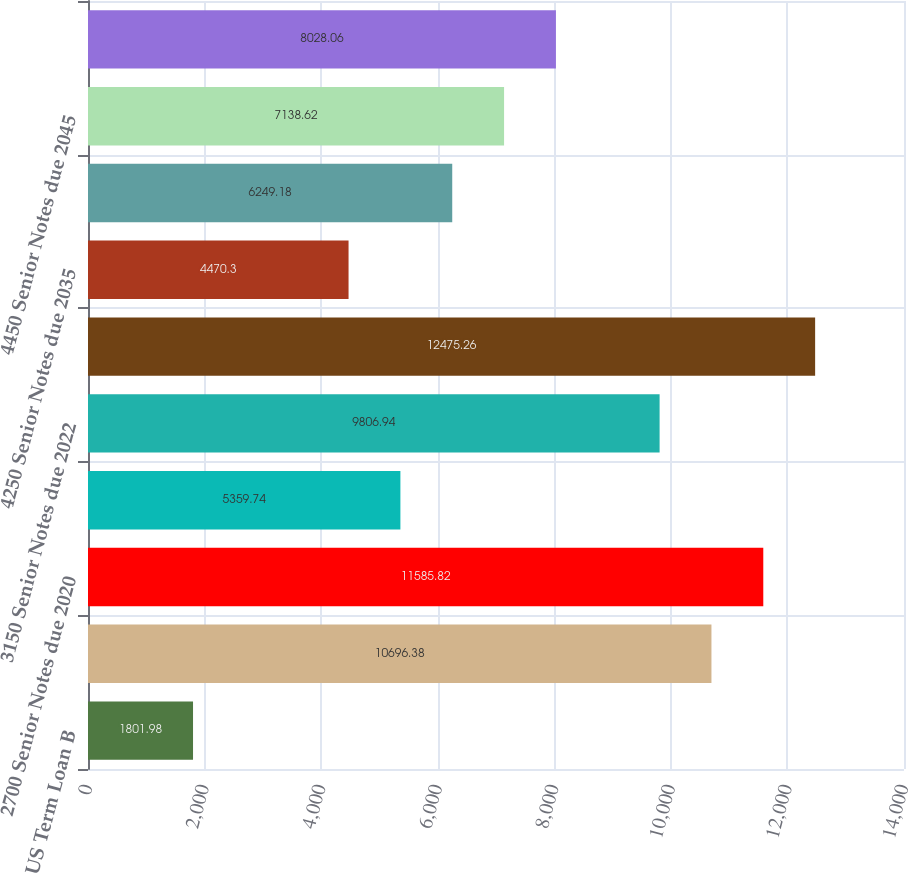<chart> <loc_0><loc_0><loc_500><loc_500><bar_chart><fcel>US Term Loan B<fcel>Total short-term debt<fcel>2700 Senior Notes due 2020<fcel>3375 Senior Notes due 2021<fcel>3150 Senior Notes due 2022<fcel>3550 Senior Notes due 2025<fcel>4250 Senior Notes due 2035<fcel>5750 Senior Notes due 2039<fcel>4450 Senior Notes due 2045<fcel>1414 Euro Notes due 2022<nl><fcel>1801.98<fcel>10696.4<fcel>11585.8<fcel>5359.74<fcel>9806.94<fcel>12475.3<fcel>4470.3<fcel>6249.18<fcel>7138.62<fcel>8028.06<nl></chart> 